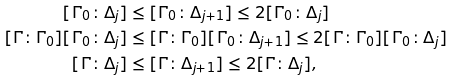<formula> <loc_0><loc_0><loc_500><loc_500>[ \Gamma _ { 0 } \colon \Delta _ { j } ] & \leq [ \Gamma _ { 0 } \colon \Delta _ { j + 1 } ] \leq 2 [ \Gamma _ { 0 } \colon \Delta _ { j } ] \\ [ \Gamma \colon \Gamma _ { 0 } ] [ \Gamma _ { 0 } \colon \Delta _ { j } ] & \leq [ \Gamma \colon \Gamma _ { 0 } ] [ \Gamma _ { 0 } \colon \Delta _ { j + 1 } ] \leq 2 [ \Gamma \colon \Gamma _ { 0 } ] [ \Gamma _ { 0 } \colon \Delta _ { j } ] \\ [ \Gamma \colon \Delta _ { j } ] & \leq [ \Gamma \colon \Delta _ { j + 1 } ] \leq 2 [ \Gamma \colon \Delta _ { j } ] ,</formula> 